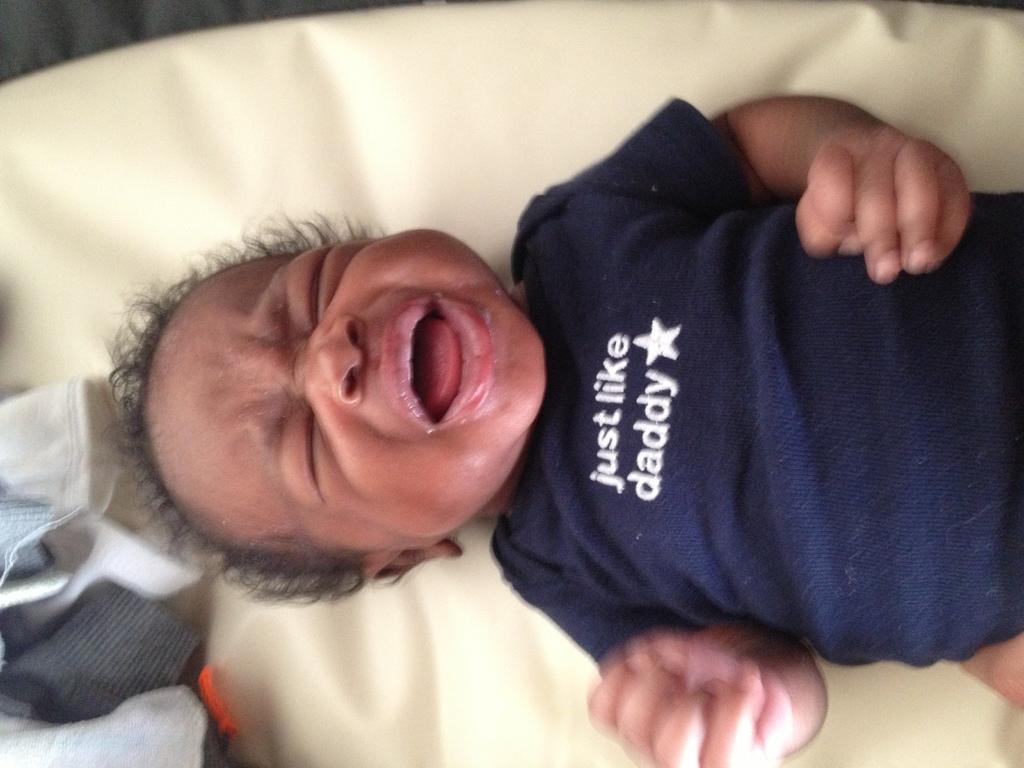Can you describe this image briefly? In this image, we can see a kid lying on an object. We can also see some clothes on the bottom left. 